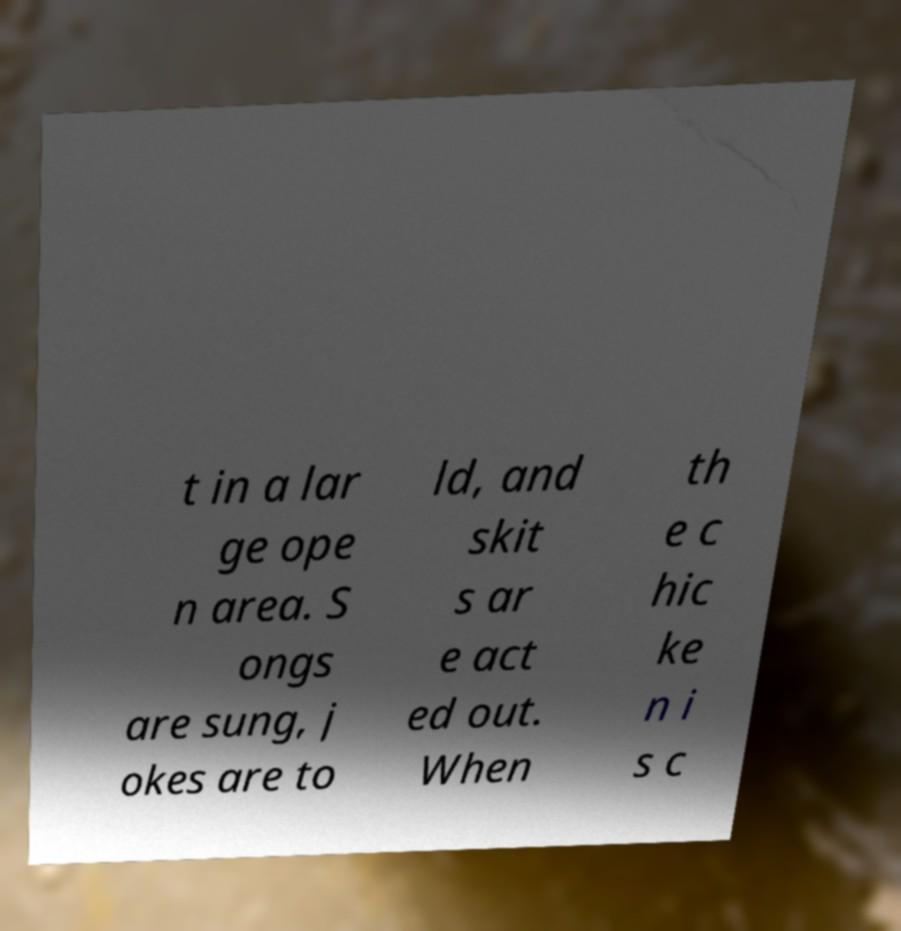Please identify and transcribe the text found in this image. t in a lar ge ope n area. S ongs are sung, j okes are to ld, and skit s ar e act ed out. When th e c hic ke n i s c 